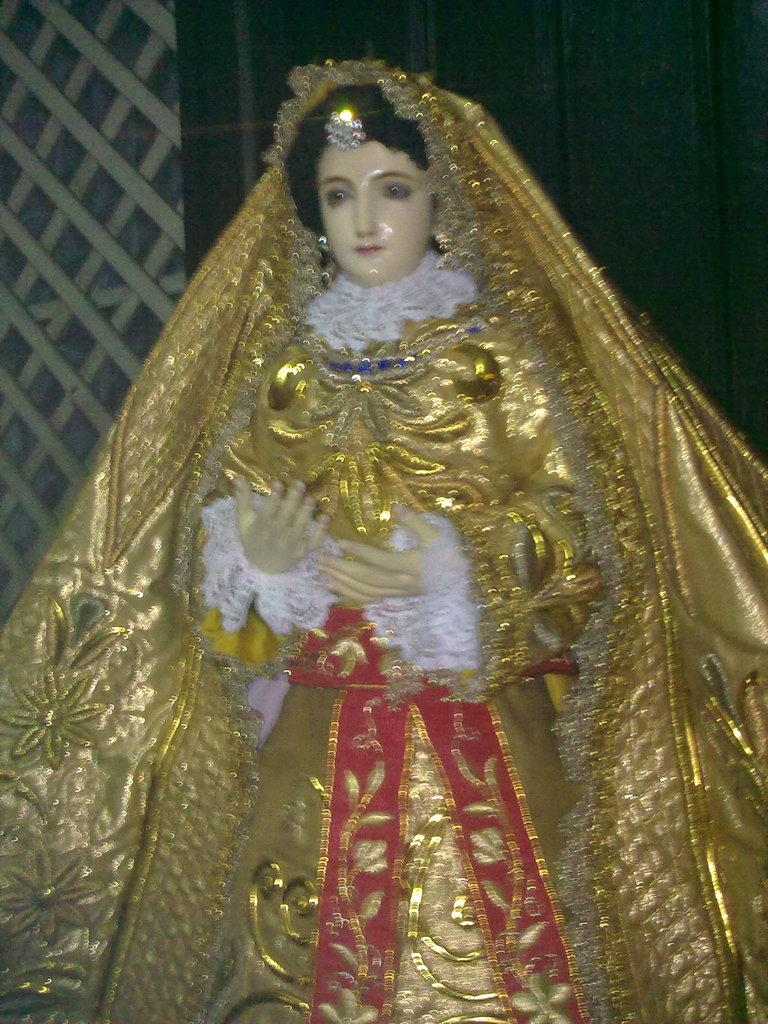What is the main subject in the image? There is a statue in the image. What is the statue wearing? The statue is wearing a gold and red color dress. What can be seen in the background of the image? There is a fountain in the background of the image. What color is the wall in the background? The wall in the background is black. What type of line is being drawn by the statue in the image? There is no line being drawn by the statue in the image; it is a stationary statue wearing a gold and red color dress. What side of the statue is facing the camera? The statue is a single, stationary object, and therefore, it does not have a specific side facing the camera. 